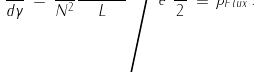Convert formula to latex. <formula><loc_0><loc_0><loc_500><loc_500>\frac { d f } { d \gamma } \, = \, \frac { 1 } { N ^ { 2 } } \frac { \langle H _ { F l u x } \rangle } { L } \Big / e ^ { 2 } \frac { N } { 2 } \, \equiv \, \rho _ { F l u x } \, .</formula> 